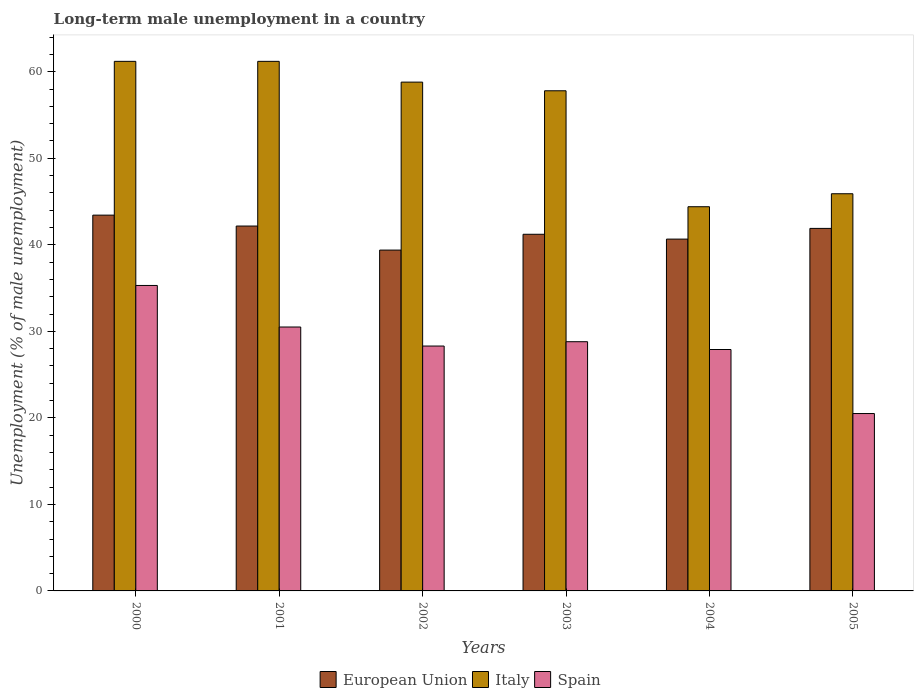How many different coloured bars are there?
Provide a succinct answer. 3. How many groups of bars are there?
Offer a very short reply. 6. Are the number of bars per tick equal to the number of legend labels?
Provide a succinct answer. Yes. How many bars are there on the 4th tick from the right?
Your response must be concise. 3. What is the percentage of long-term unemployed male population in Italy in 2004?
Provide a succinct answer. 44.4. Across all years, what is the maximum percentage of long-term unemployed male population in European Union?
Your answer should be compact. 43.43. In which year was the percentage of long-term unemployed male population in Italy minimum?
Offer a very short reply. 2004. What is the total percentage of long-term unemployed male population in European Union in the graph?
Make the answer very short. 248.76. What is the difference between the percentage of long-term unemployed male population in Italy in 2002 and the percentage of long-term unemployed male population in Spain in 2004?
Offer a very short reply. 30.9. What is the average percentage of long-term unemployed male population in European Union per year?
Give a very brief answer. 41.46. In the year 2005, what is the difference between the percentage of long-term unemployed male population in Italy and percentage of long-term unemployed male population in Spain?
Provide a succinct answer. 25.4. What is the ratio of the percentage of long-term unemployed male population in Spain in 2000 to that in 2001?
Your answer should be compact. 1.16. What is the difference between the highest and the second highest percentage of long-term unemployed male population in Spain?
Ensure brevity in your answer.  4.8. What is the difference between the highest and the lowest percentage of long-term unemployed male population in Spain?
Keep it short and to the point. 14.8. In how many years, is the percentage of long-term unemployed male population in Spain greater than the average percentage of long-term unemployed male population in Spain taken over all years?
Your response must be concise. 3. Is the sum of the percentage of long-term unemployed male population in Spain in 2000 and 2003 greater than the maximum percentage of long-term unemployed male population in Italy across all years?
Offer a terse response. Yes. What does the 1st bar from the left in 2003 represents?
Your answer should be very brief. European Union. Is it the case that in every year, the sum of the percentage of long-term unemployed male population in Italy and percentage of long-term unemployed male population in European Union is greater than the percentage of long-term unemployed male population in Spain?
Keep it short and to the point. Yes. Are the values on the major ticks of Y-axis written in scientific E-notation?
Your answer should be very brief. No. Does the graph contain any zero values?
Make the answer very short. No. Does the graph contain grids?
Give a very brief answer. No. How many legend labels are there?
Your response must be concise. 3. What is the title of the graph?
Offer a very short reply. Long-term male unemployment in a country. Does "Vanuatu" appear as one of the legend labels in the graph?
Provide a succinct answer. No. What is the label or title of the Y-axis?
Keep it short and to the point. Unemployment (% of male unemployment). What is the Unemployment (% of male unemployment) in European Union in 2000?
Keep it short and to the point. 43.43. What is the Unemployment (% of male unemployment) of Italy in 2000?
Your response must be concise. 61.2. What is the Unemployment (% of male unemployment) of Spain in 2000?
Your answer should be very brief. 35.3. What is the Unemployment (% of male unemployment) of European Union in 2001?
Offer a very short reply. 42.17. What is the Unemployment (% of male unemployment) of Italy in 2001?
Give a very brief answer. 61.2. What is the Unemployment (% of male unemployment) in Spain in 2001?
Provide a short and direct response. 30.5. What is the Unemployment (% of male unemployment) of European Union in 2002?
Your answer should be very brief. 39.39. What is the Unemployment (% of male unemployment) in Italy in 2002?
Ensure brevity in your answer.  58.8. What is the Unemployment (% of male unemployment) of Spain in 2002?
Offer a very short reply. 28.3. What is the Unemployment (% of male unemployment) of European Union in 2003?
Keep it short and to the point. 41.22. What is the Unemployment (% of male unemployment) of Italy in 2003?
Offer a terse response. 57.8. What is the Unemployment (% of male unemployment) in Spain in 2003?
Keep it short and to the point. 28.8. What is the Unemployment (% of male unemployment) in European Union in 2004?
Your answer should be very brief. 40.66. What is the Unemployment (% of male unemployment) in Italy in 2004?
Your answer should be very brief. 44.4. What is the Unemployment (% of male unemployment) in Spain in 2004?
Your answer should be compact. 27.9. What is the Unemployment (% of male unemployment) of European Union in 2005?
Provide a succinct answer. 41.9. What is the Unemployment (% of male unemployment) of Italy in 2005?
Give a very brief answer. 45.9. Across all years, what is the maximum Unemployment (% of male unemployment) of European Union?
Your answer should be compact. 43.43. Across all years, what is the maximum Unemployment (% of male unemployment) of Italy?
Offer a very short reply. 61.2. Across all years, what is the maximum Unemployment (% of male unemployment) of Spain?
Provide a succinct answer. 35.3. Across all years, what is the minimum Unemployment (% of male unemployment) in European Union?
Your answer should be compact. 39.39. Across all years, what is the minimum Unemployment (% of male unemployment) in Italy?
Provide a short and direct response. 44.4. What is the total Unemployment (% of male unemployment) of European Union in the graph?
Your response must be concise. 248.76. What is the total Unemployment (% of male unemployment) of Italy in the graph?
Your answer should be compact. 329.3. What is the total Unemployment (% of male unemployment) in Spain in the graph?
Ensure brevity in your answer.  171.3. What is the difference between the Unemployment (% of male unemployment) in European Union in 2000 and that in 2001?
Provide a succinct answer. 1.26. What is the difference between the Unemployment (% of male unemployment) of European Union in 2000 and that in 2002?
Ensure brevity in your answer.  4.04. What is the difference between the Unemployment (% of male unemployment) in Italy in 2000 and that in 2002?
Your answer should be compact. 2.4. What is the difference between the Unemployment (% of male unemployment) of Spain in 2000 and that in 2002?
Offer a very short reply. 7. What is the difference between the Unemployment (% of male unemployment) in European Union in 2000 and that in 2003?
Ensure brevity in your answer.  2.21. What is the difference between the Unemployment (% of male unemployment) of European Union in 2000 and that in 2004?
Provide a succinct answer. 2.77. What is the difference between the Unemployment (% of male unemployment) of Spain in 2000 and that in 2004?
Ensure brevity in your answer.  7.4. What is the difference between the Unemployment (% of male unemployment) of European Union in 2000 and that in 2005?
Your answer should be very brief. 1.53. What is the difference between the Unemployment (% of male unemployment) of Italy in 2000 and that in 2005?
Keep it short and to the point. 15.3. What is the difference between the Unemployment (% of male unemployment) in European Union in 2001 and that in 2002?
Give a very brief answer. 2.78. What is the difference between the Unemployment (% of male unemployment) of Italy in 2001 and that in 2002?
Your answer should be very brief. 2.4. What is the difference between the Unemployment (% of male unemployment) of Spain in 2001 and that in 2002?
Keep it short and to the point. 2.2. What is the difference between the Unemployment (% of male unemployment) in European Union in 2001 and that in 2003?
Offer a terse response. 0.95. What is the difference between the Unemployment (% of male unemployment) in Italy in 2001 and that in 2003?
Give a very brief answer. 3.4. What is the difference between the Unemployment (% of male unemployment) in European Union in 2001 and that in 2004?
Offer a terse response. 1.51. What is the difference between the Unemployment (% of male unemployment) of Italy in 2001 and that in 2004?
Your answer should be compact. 16.8. What is the difference between the Unemployment (% of male unemployment) in European Union in 2001 and that in 2005?
Provide a short and direct response. 0.27. What is the difference between the Unemployment (% of male unemployment) in Spain in 2001 and that in 2005?
Your answer should be very brief. 10. What is the difference between the Unemployment (% of male unemployment) in European Union in 2002 and that in 2003?
Ensure brevity in your answer.  -1.83. What is the difference between the Unemployment (% of male unemployment) in European Union in 2002 and that in 2004?
Provide a short and direct response. -1.27. What is the difference between the Unemployment (% of male unemployment) of Italy in 2002 and that in 2004?
Provide a succinct answer. 14.4. What is the difference between the Unemployment (% of male unemployment) of Spain in 2002 and that in 2004?
Your response must be concise. 0.4. What is the difference between the Unemployment (% of male unemployment) in European Union in 2002 and that in 2005?
Provide a short and direct response. -2.51. What is the difference between the Unemployment (% of male unemployment) of European Union in 2003 and that in 2004?
Provide a succinct answer. 0.56. What is the difference between the Unemployment (% of male unemployment) in Italy in 2003 and that in 2004?
Your answer should be very brief. 13.4. What is the difference between the Unemployment (% of male unemployment) in Spain in 2003 and that in 2004?
Offer a terse response. 0.9. What is the difference between the Unemployment (% of male unemployment) in European Union in 2003 and that in 2005?
Offer a terse response. -0.68. What is the difference between the Unemployment (% of male unemployment) of Italy in 2003 and that in 2005?
Make the answer very short. 11.9. What is the difference between the Unemployment (% of male unemployment) in Spain in 2003 and that in 2005?
Offer a terse response. 8.3. What is the difference between the Unemployment (% of male unemployment) of European Union in 2004 and that in 2005?
Keep it short and to the point. -1.24. What is the difference between the Unemployment (% of male unemployment) in Italy in 2004 and that in 2005?
Your response must be concise. -1.5. What is the difference between the Unemployment (% of male unemployment) in Spain in 2004 and that in 2005?
Offer a terse response. 7.4. What is the difference between the Unemployment (% of male unemployment) in European Union in 2000 and the Unemployment (% of male unemployment) in Italy in 2001?
Provide a short and direct response. -17.77. What is the difference between the Unemployment (% of male unemployment) of European Union in 2000 and the Unemployment (% of male unemployment) of Spain in 2001?
Provide a succinct answer. 12.93. What is the difference between the Unemployment (% of male unemployment) of Italy in 2000 and the Unemployment (% of male unemployment) of Spain in 2001?
Offer a terse response. 30.7. What is the difference between the Unemployment (% of male unemployment) in European Union in 2000 and the Unemployment (% of male unemployment) in Italy in 2002?
Provide a short and direct response. -15.37. What is the difference between the Unemployment (% of male unemployment) of European Union in 2000 and the Unemployment (% of male unemployment) of Spain in 2002?
Provide a short and direct response. 15.13. What is the difference between the Unemployment (% of male unemployment) in Italy in 2000 and the Unemployment (% of male unemployment) in Spain in 2002?
Your answer should be very brief. 32.9. What is the difference between the Unemployment (% of male unemployment) in European Union in 2000 and the Unemployment (% of male unemployment) in Italy in 2003?
Offer a terse response. -14.37. What is the difference between the Unemployment (% of male unemployment) in European Union in 2000 and the Unemployment (% of male unemployment) in Spain in 2003?
Provide a short and direct response. 14.63. What is the difference between the Unemployment (% of male unemployment) of Italy in 2000 and the Unemployment (% of male unemployment) of Spain in 2003?
Offer a very short reply. 32.4. What is the difference between the Unemployment (% of male unemployment) in European Union in 2000 and the Unemployment (% of male unemployment) in Italy in 2004?
Your response must be concise. -0.97. What is the difference between the Unemployment (% of male unemployment) in European Union in 2000 and the Unemployment (% of male unemployment) in Spain in 2004?
Provide a short and direct response. 15.53. What is the difference between the Unemployment (% of male unemployment) in Italy in 2000 and the Unemployment (% of male unemployment) in Spain in 2004?
Provide a short and direct response. 33.3. What is the difference between the Unemployment (% of male unemployment) in European Union in 2000 and the Unemployment (% of male unemployment) in Italy in 2005?
Provide a succinct answer. -2.47. What is the difference between the Unemployment (% of male unemployment) of European Union in 2000 and the Unemployment (% of male unemployment) of Spain in 2005?
Provide a succinct answer. 22.93. What is the difference between the Unemployment (% of male unemployment) in Italy in 2000 and the Unemployment (% of male unemployment) in Spain in 2005?
Provide a succinct answer. 40.7. What is the difference between the Unemployment (% of male unemployment) of European Union in 2001 and the Unemployment (% of male unemployment) of Italy in 2002?
Keep it short and to the point. -16.63. What is the difference between the Unemployment (% of male unemployment) in European Union in 2001 and the Unemployment (% of male unemployment) in Spain in 2002?
Give a very brief answer. 13.87. What is the difference between the Unemployment (% of male unemployment) in Italy in 2001 and the Unemployment (% of male unemployment) in Spain in 2002?
Your response must be concise. 32.9. What is the difference between the Unemployment (% of male unemployment) of European Union in 2001 and the Unemployment (% of male unemployment) of Italy in 2003?
Give a very brief answer. -15.63. What is the difference between the Unemployment (% of male unemployment) in European Union in 2001 and the Unemployment (% of male unemployment) in Spain in 2003?
Provide a short and direct response. 13.37. What is the difference between the Unemployment (% of male unemployment) in Italy in 2001 and the Unemployment (% of male unemployment) in Spain in 2003?
Provide a short and direct response. 32.4. What is the difference between the Unemployment (% of male unemployment) in European Union in 2001 and the Unemployment (% of male unemployment) in Italy in 2004?
Give a very brief answer. -2.23. What is the difference between the Unemployment (% of male unemployment) in European Union in 2001 and the Unemployment (% of male unemployment) in Spain in 2004?
Ensure brevity in your answer.  14.27. What is the difference between the Unemployment (% of male unemployment) in Italy in 2001 and the Unemployment (% of male unemployment) in Spain in 2004?
Offer a very short reply. 33.3. What is the difference between the Unemployment (% of male unemployment) in European Union in 2001 and the Unemployment (% of male unemployment) in Italy in 2005?
Provide a short and direct response. -3.73. What is the difference between the Unemployment (% of male unemployment) in European Union in 2001 and the Unemployment (% of male unemployment) in Spain in 2005?
Keep it short and to the point. 21.67. What is the difference between the Unemployment (% of male unemployment) in Italy in 2001 and the Unemployment (% of male unemployment) in Spain in 2005?
Your answer should be compact. 40.7. What is the difference between the Unemployment (% of male unemployment) in European Union in 2002 and the Unemployment (% of male unemployment) in Italy in 2003?
Offer a terse response. -18.41. What is the difference between the Unemployment (% of male unemployment) of European Union in 2002 and the Unemployment (% of male unemployment) of Spain in 2003?
Offer a terse response. 10.59. What is the difference between the Unemployment (% of male unemployment) of European Union in 2002 and the Unemployment (% of male unemployment) of Italy in 2004?
Ensure brevity in your answer.  -5.01. What is the difference between the Unemployment (% of male unemployment) in European Union in 2002 and the Unemployment (% of male unemployment) in Spain in 2004?
Give a very brief answer. 11.49. What is the difference between the Unemployment (% of male unemployment) of Italy in 2002 and the Unemployment (% of male unemployment) of Spain in 2004?
Provide a succinct answer. 30.9. What is the difference between the Unemployment (% of male unemployment) in European Union in 2002 and the Unemployment (% of male unemployment) in Italy in 2005?
Ensure brevity in your answer.  -6.51. What is the difference between the Unemployment (% of male unemployment) in European Union in 2002 and the Unemployment (% of male unemployment) in Spain in 2005?
Your answer should be very brief. 18.89. What is the difference between the Unemployment (% of male unemployment) of Italy in 2002 and the Unemployment (% of male unemployment) of Spain in 2005?
Ensure brevity in your answer.  38.3. What is the difference between the Unemployment (% of male unemployment) of European Union in 2003 and the Unemployment (% of male unemployment) of Italy in 2004?
Give a very brief answer. -3.18. What is the difference between the Unemployment (% of male unemployment) in European Union in 2003 and the Unemployment (% of male unemployment) in Spain in 2004?
Your answer should be compact. 13.32. What is the difference between the Unemployment (% of male unemployment) of Italy in 2003 and the Unemployment (% of male unemployment) of Spain in 2004?
Give a very brief answer. 29.9. What is the difference between the Unemployment (% of male unemployment) in European Union in 2003 and the Unemployment (% of male unemployment) in Italy in 2005?
Your response must be concise. -4.68. What is the difference between the Unemployment (% of male unemployment) of European Union in 2003 and the Unemployment (% of male unemployment) of Spain in 2005?
Provide a short and direct response. 20.72. What is the difference between the Unemployment (% of male unemployment) in Italy in 2003 and the Unemployment (% of male unemployment) in Spain in 2005?
Make the answer very short. 37.3. What is the difference between the Unemployment (% of male unemployment) of European Union in 2004 and the Unemployment (% of male unemployment) of Italy in 2005?
Offer a terse response. -5.24. What is the difference between the Unemployment (% of male unemployment) of European Union in 2004 and the Unemployment (% of male unemployment) of Spain in 2005?
Your answer should be very brief. 20.16. What is the difference between the Unemployment (% of male unemployment) in Italy in 2004 and the Unemployment (% of male unemployment) in Spain in 2005?
Your answer should be very brief. 23.9. What is the average Unemployment (% of male unemployment) of European Union per year?
Your answer should be very brief. 41.46. What is the average Unemployment (% of male unemployment) in Italy per year?
Keep it short and to the point. 54.88. What is the average Unemployment (% of male unemployment) in Spain per year?
Offer a terse response. 28.55. In the year 2000, what is the difference between the Unemployment (% of male unemployment) in European Union and Unemployment (% of male unemployment) in Italy?
Ensure brevity in your answer.  -17.77. In the year 2000, what is the difference between the Unemployment (% of male unemployment) of European Union and Unemployment (% of male unemployment) of Spain?
Offer a very short reply. 8.13. In the year 2000, what is the difference between the Unemployment (% of male unemployment) of Italy and Unemployment (% of male unemployment) of Spain?
Your answer should be compact. 25.9. In the year 2001, what is the difference between the Unemployment (% of male unemployment) in European Union and Unemployment (% of male unemployment) in Italy?
Keep it short and to the point. -19.03. In the year 2001, what is the difference between the Unemployment (% of male unemployment) of European Union and Unemployment (% of male unemployment) of Spain?
Your answer should be very brief. 11.67. In the year 2001, what is the difference between the Unemployment (% of male unemployment) of Italy and Unemployment (% of male unemployment) of Spain?
Your response must be concise. 30.7. In the year 2002, what is the difference between the Unemployment (% of male unemployment) in European Union and Unemployment (% of male unemployment) in Italy?
Your answer should be very brief. -19.41. In the year 2002, what is the difference between the Unemployment (% of male unemployment) of European Union and Unemployment (% of male unemployment) of Spain?
Your answer should be very brief. 11.09. In the year 2002, what is the difference between the Unemployment (% of male unemployment) in Italy and Unemployment (% of male unemployment) in Spain?
Keep it short and to the point. 30.5. In the year 2003, what is the difference between the Unemployment (% of male unemployment) in European Union and Unemployment (% of male unemployment) in Italy?
Provide a succinct answer. -16.58. In the year 2003, what is the difference between the Unemployment (% of male unemployment) of European Union and Unemployment (% of male unemployment) of Spain?
Ensure brevity in your answer.  12.42. In the year 2003, what is the difference between the Unemployment (% of male unemployment) of Italy and Unemployment (% of male unemployment) of Spain?
Your answer should be very brief. 29. In the year 2004, what is the difference between the Unemployment (% of male unemployment) in European Union and Unemployment (% of male unemployment) in Italy?
Provide a short and direct response. -3.74. In the year 2004, what is the difference between the Unemployment (% of male unemployment) of European Union and Unemployment (% of male unemployment) of Spain?
Make the answer very short. 12.76. In the year 2005, what is the difference between the Unemployment (% of male unemployment) in European Union and Unemployment (% of male unemployment) in Italy?
Offer a terse response. -4. In the year 2005, what is the difference between the Unemployment (% of male unemployment) of European Union and Unemployment (% of male unemployment) of Spain?
Make the answer very short. 21.4. In the year 2005, what is the difference between the Unemployment (% of male unemployment) in Italy and Unemployment (% of male unemployment) in Spain?
Make the answer very short. 25.4. What is the ratio of the Unemployment (% of male unemployment) in European Union in 2000 to that in 2001?
Make the answer very short. 1.03. What is the ratio of the Unemployment (% of male unemployment) of Italy in 2000 to that in 2001?
Offer a very short reply. 1. What is the ratio of the Unemployment (% of male unemployment) of Spain in 2000 to that in 2001?
Offer a very short reply. 1.16. What is the ratio of the Unemployment (% of male unemployment) of European Union in 2000 to that in 2002?
Ensure brevity in your answer.  1.1. What is the ratio of the Unemployment (% of male unemployment) of Italy in 2000 to that in 2002?
Provide a succinct answer. 1.04. What is the ratio of the Unemployment (% of male unemployment) in Spain in 2000 to that in 2002?
Make the answer very short. 1.25. What is the ratio of the Unemployment (% of male unemployment) in European Union in 2000 to that in 2003?
Your answer should be very brief. 1.05. What is the ratio of the Unemployment (% of male unemployment) in Italy in 2000 to that in 2003?
Give a very brief answer. 1.06. What is the ratio of the Unemployment (% of male unemployment) of Spain in 2000 to that in 2003?
Offer a very short reply. 1.23. What is the ratio of the Unemployment (% of male unemployment) in European Union in 2000 to that in 2004?
Offer a very short reply. 1.07. What is the ratio of the Unemployment (% of male unemployment) in Italy in 2000 to that in 2004?
Offer a very short reply. 1.38. What is the ratio of the Unemployment (% of male unemployment) of Spain in 2000 to that in 2004?
Provide a short and direct response. 1.27. What is the ratio of the Unemployment (% of male unemployment) in European Union in 2000 to that in 2005?
Keep it short and to the point. 1.04. What is the ratio of the Unemployment (% of male unemployment) of Italy in 2000 to that in 2005?
Provide a succinct answer. 1.33. What is the ratio of the Unemployment (% of male unemployment) in Spain in 2000 to that in 2005?
Offer a very short reply. 1.72. What is the ratio of the Unemployment (% of male unemployment) in European Union in 2001 to that in 2002?
Offer a terse response. 1.07. What is the ratio of the Unemployment (% of male unemployment) in Italy in 2001 to that in 2002?
Make the answer very short. 1.04. What is the ratio of the Unemployment (% of male unemployment) of Spain in 2001 to that in 2002?
Your answer should be very brief. 1.08. What is the ratio of the Unemployment (% of male unemployment) in European Union in 2001 to that in 2003?
Offer a terse response. 1.02. What is the ratio of the Unemployment (% of male unemployment) in Italy in 2001 to that in 2003?
Your response must be concise. 1.06. What is the ratio of the Unemployment (% of male unemployment) of Spain in 2001 to that in 2003?
Your response must be concise. 1.06. What is the ratio of the Unemployment (% of male unemployment) in European Union in 2001 to that in 2004?
Your response must be concise. 1.04. What is the ratio of the Unemployment (% of male unemployment) of Italy in 2001 to that in 2004?
Your answer should be very brief. 1.38. What is the ratio of the Unemployment (% of male unemployment) of Spain in 2001 to that in 2004?
Your answer should be very brief. 1.09. What is the ratio of the Unemployment (% of male unemployment) of European Union in 2001 to that in 2005?
Give a very brief answer. 1.01. What is the ratio of the Unemployment (% of male unemployment) of Spain in 2001 to that in 2005?
Ensure brevity in your answer.  1.49. What is the ratio of the Unemployment (% of male unemployment) of European Union in 2002 to that in 2003?
Your answer should be very brief. 0.96. What is the ratio of the Unemployment (% of male unemployment) in Italy in 2002 to that in 2003?
Offer a very short reply. 1.02. What is the ratio of the Unemployment (% of male unemployment) in Spain in 2002 to that in 2003?
Make the answer very short. 0.98. What is the ratio of the Unemployment (% of male unemployment) in European Union in 2002 to that in 2004?
Your answer should be compact. 0.97. What is the ratio of the Unemployment (% of male unemployment) of Italy in 2002 to that in 2004?
Offer a terse response. 1.32. What is the ratio of the Unemployment (% of male unemployment) of Spain in 2002 to that in 2004?
Offer a very short reply. 1.01. What is the ratio of the Unemployment (% of male unemployment) of European Union in 2002 to that in 2005?
Your answer should be very brief. 0.94. What is the ratio of the Unemployment (% of male unemployment) of Italy in 2002 to that in 2005?
Your response must be concise. 1.28. What is the ratio of the Unemployment (% of male unemployment) in Spain in 2002 to that in 2005?
Keep it short and to the point. 1.38. What is the ratio of the Unemployment (% of male unemployment) in European Union in 2003 to that in 2004?
Offer a terse response. 1.01. What is the ratio of the Unemployment (% of male unemployment) in Italy in 2003 to that in 2004?
Offer a very short reply. 1.3. What is the ratio of the Unemployment (% of male unemployment) of Spain in 2003 to that in 2004?
Provide a short and direct response. 1.03. What is the ratio of the Unemployment (% of male unemployment) of European Union in 2003 to that in 2005?
Give a very brief answer. 0.98. What is the ratio of the Unemployment (% of male unemployment) in Italy in 2003 to that in 2005?
Your answer should be compact. 1.26. What is the ratio of the Unemployment (% of male unemployment) of Spain in 2003 to that in 2005?
Give a very brief answer. 1.4. What is the ratio of the Unemployment (% of male unemployment) in European Union in 2004 to that in 2005?
Offer a terse response. 0.97. What is the ratio of the Unemployment (% of male unemployment) of Italy in 2004 to that in 2005?
Keep it short and to the point. 0.97. What is the ratio of the Unemployment (% of male unemployment) of Spain in 2004 to that in 2005?
Make the answer very short. 1.36. What is the difference between the highest and the second highest Unemployment (% of male unemployment) of European Union?
Provide a succinct answer. 1.26. What is the difference between the highest and the second highest Unemployment (% of male unemployment) in Italy?
Ensure brevity in your answer.  0. What is the difference between the highest and the lowest Unemployment (% of male unemployment) of European Union?
Keep it short and to the point. 4.04. What is the difference between the highest and the lowest Unemployment (% of male unemployment) of Italy?
Your response must be concise. 16.8. What is the difference between the highest and the lowest Unemployment (% of male unemployment) in Spain?
Keep it short and to the point. 14.8. 